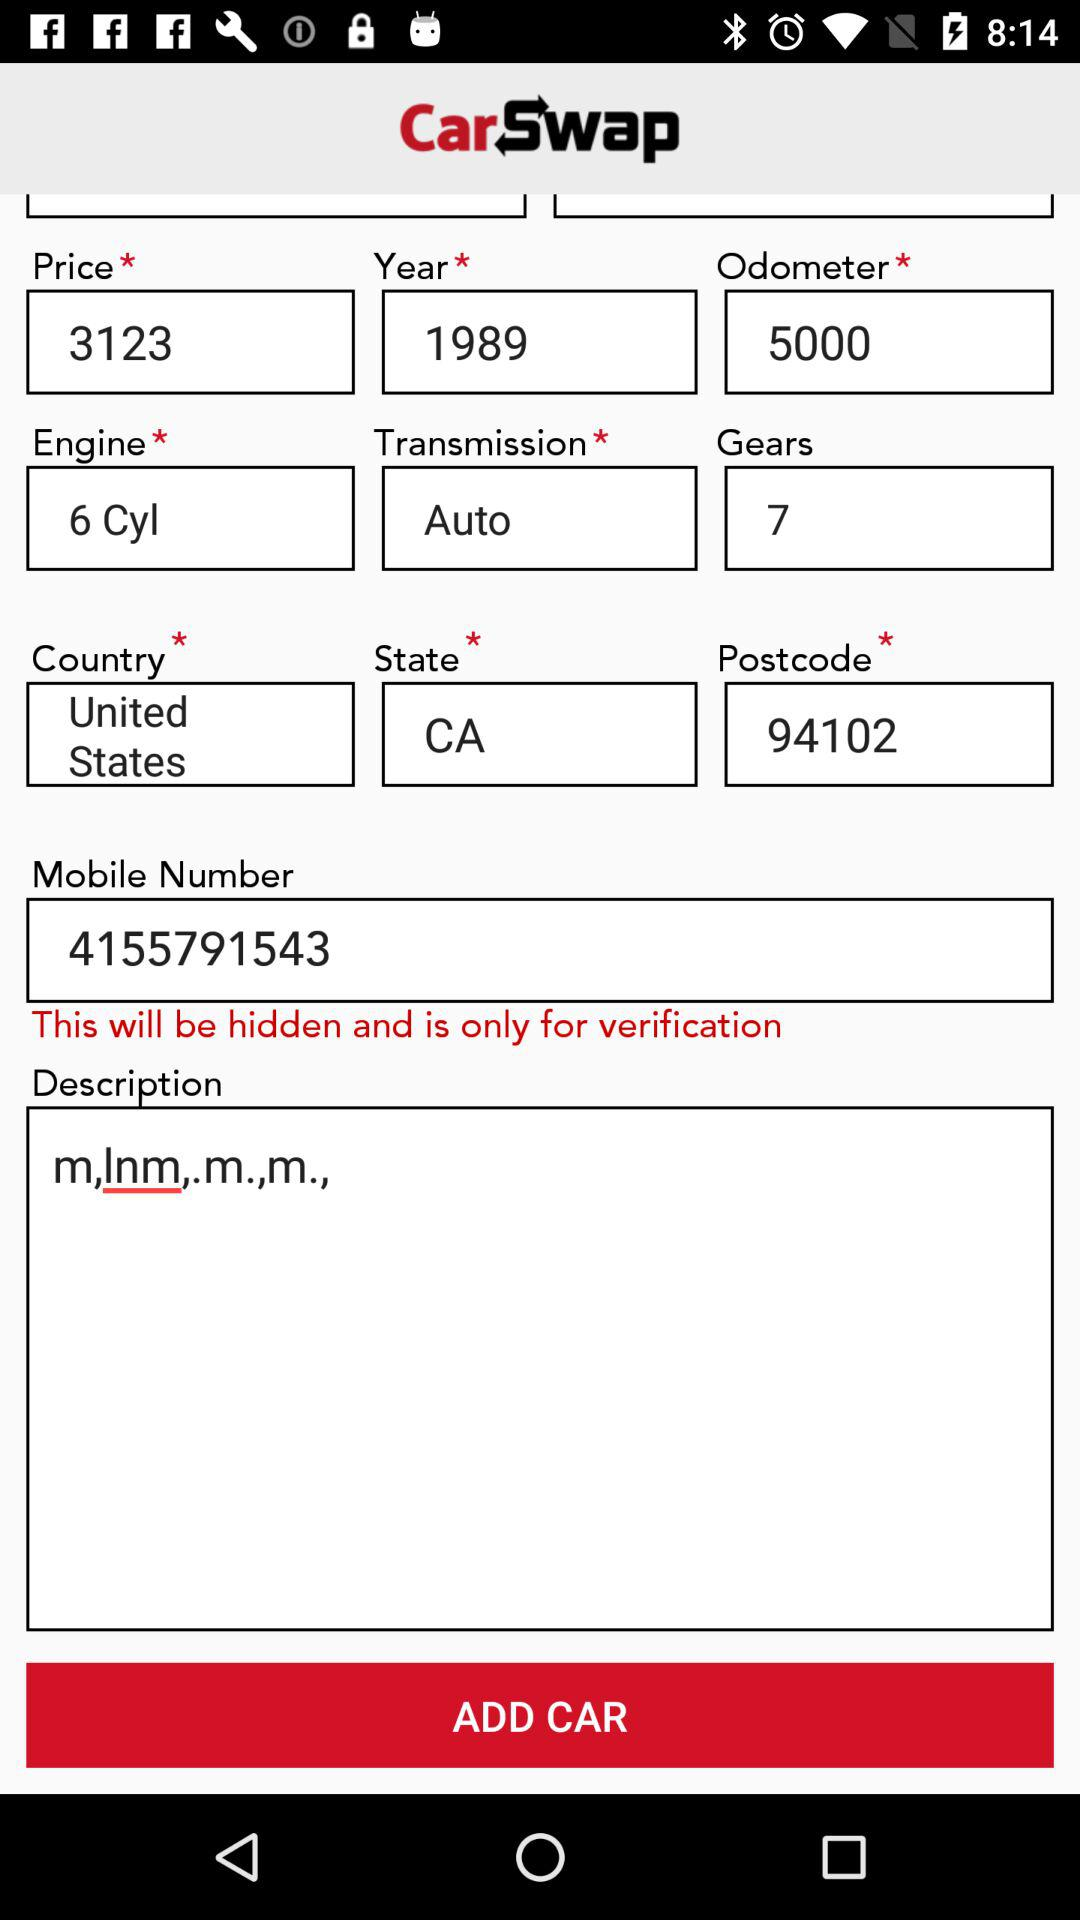How many gears does the user have filled in the form? The user has filled in 7 gears in the form. 